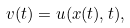Convert formula to latex. <formula><loc_0><loc_0><loc_500><loc_500>v ( t ) = u ( x ( t ) , t ) ,</formula> 